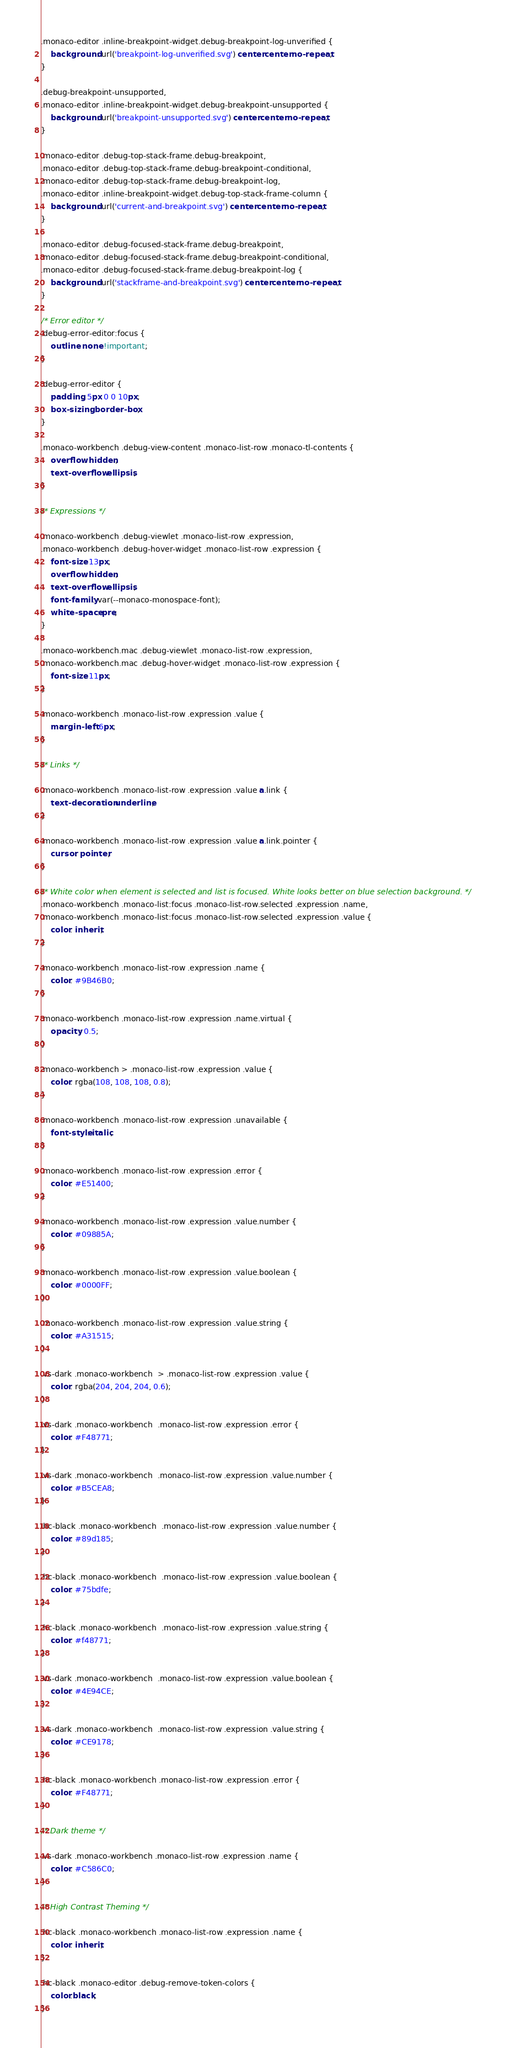Convert code to text. <code><loc_0><loc_0><loc_500><loc_500><_CSS_>.monaco-editor .inline-breakpoint-widget.debug-breakpoint-log-unverified {
	background: url('breakpoint-log-unverified.svg') center center no-repeat;
}

.debug-breakpoint-unsupported,
.monaco-editor .inline-breakpoint-widget.debug-breakpoint-unsupported {
	background: url('breakpoint-unsupported.svg') center center no-repeat;
}

.monaco-editor .debug-top-stack-frame.debug-breakpoint,
.monaco-editor .debug-top-stack-frame.debug-breakpoint-conditional,
.monaco-editor .debug-top-stack-frame.debug-breakpoint-log,
.monaco-editor .inline-breakpoint-widget.debug-top-stack-frame-column {
	background: url('current-and-breakpoint.svg') center center no-repeat;
}

.monaco-editor .debug-focused-stack-frame.debug-breakpoint,
.monaco-editor .debug-focused-stack-frame.debug-breakpoint-conditional,
.monaco-editor .debug-focused-stack-frame.debug-breakpoint-log {
	background: url('stackframe-and-breakpoint.svg') center center no-repeat;
}

/* Error editor */
.debug-error-editor:focus {
	outline: none !important;
}

.debug-error-editor {
	padding: 5px 0 0 10px;
	box-sizing: border-box;
}

.monaco-workbench .debug-view-content .monaco-list-row .monaco-tl-contents {
	overflow: hidden;
	text-overflow: ellipsis;
}

/* Expressions */

.monaco-workbench .debug-viewlet .monaco-list-row .expression,
.monaco-workbench .debug-hover-widget .monaco-list-row .expression {
	font-size: 13px;
	overflow: hidden;
	text-overflow: ellipsis;
	font-family: var(--monaco-monospace-font);
	white-space: pre;
}

.monaco-workbench.mac .debug-viewlet .monaco-list-row .expression,
.monaco-workbench.mac .debug-hover-widget .monaco-list-row .expression {
	font-size: 11px;
}

.monaco-workbench .monaco-list-row .expression .value {
	margin-left: 6px;
}

/* Links */

.monaco-workbench .monaco-list-row .expression .value a.link {
	text-decoration: underline;
}

.monaco-workbench .monaco-list-row .expression .value a.link.pointer {
	cursor: pointer;
}

/* White color when element is selected and list is focused. White looks better on blue selection background. */
.monaco-workbench .monaco-list:focus .monaco-list-row.selected .expression .name,
.monaco-workbench .monaco-list:focus .monaco-list-row.selected .expression .value {
	color: inherit;
}

.monaco-workbench .monaco-list-row .expression .name {
	color: #9B46B0;
}

.monaco-workbench .monaco-list-row .expression .name.virtual {
	opacity: 0.5;
}

.monaco-workbench > .monaco-list-row .expression .value {
	color: rgba(108, 108, 108, 0.8);
}

.monaco-workbench .monaco-list-row .expression .unavailable {
	font-style: italic;
}

.monaco-workbench .monaco-list-row .expression .error {
	color: #E51400;
}

.monaco-workbench .monaco-list-row .expression .value.number {
	color: #09885A;
}

.monaco-workbench .monaco-list-row .expression .value.boolean {
	color: #0000FF;
}

.monaco-workbench .monaco-list-row .expression .value.string {
	color: #A31515;
}

.vs-dark .monaco-workbench  > .monaco-list-row .expression .value {
	color: rgba(204, 204, 204, 0.6);
}

.vs-dark .monaco-workbench  .monaco-list-row .expression .error {
	color: #F48771;
}

.vs-dark .monaco-workbench  .monaco-list-row .expression .value.number {
	color: #B5CEA8;
}

.hc-black .monaco-workbench  .monaco-list-row .expression .value.number {
	color: #89d185;
}

.hc-black .monaco-workbench  .monaco-list-row .expression .value.boolean {
	color: #75bdfe;
}

.hc-black .monaco-workbench  .monaco-list-row .expression .value.string {
	color: #f48771;
}

.vs-dark .monaco-workbench  .monaco-list-row .expression .value.boolean {
	color: #4E94CE;
}

.vs-dark .monaco-workbench  .monaco-list-row .expression .value.string {
	color: #CE9178;
}

.hc-black .monaco-workbench .monaco-list-row .expression .error {
	color: #F48771;
}

/* Dark theme */

.vs-dark .monaco-workbench .monaco-list-row .expression .name {
	color: #C586C0;
}

/* High Contrast Theming */

.hc-black .monaco-workbench .monaco-list-row .expression .name {
	color: inherit;
}

.hc-black .monaco-editor .debug-remove-token-colors {
	color:black;
}
</code> 